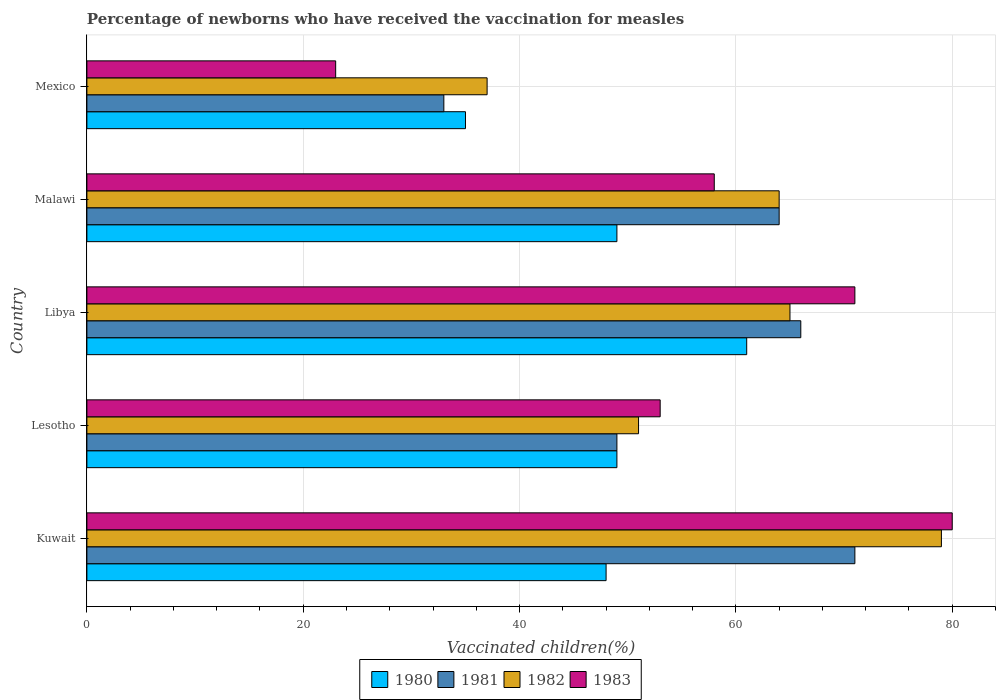How many different coloured bars are there?
Provide a succinct answer. 4. Are the number of bars on each tick of the Y-axis equal?
Keep it short and to the point. Yes. What is the label of the 2nd group of bars from the top?
Your answer should be very brief. Malawi. In how many cases, is the number of bars for a given country not equal to the number of legend labels?
Offer a terse response. 0. What is the percentage of vaccinated children in 1983 in Mexico?
Make the answer very short. 23. Across all countries, what is the maximum percentage of vaccinated children in 1980?
Provide a succinct answer. 61. In which country was the percentage of vaccinated children in 1982 maximum?
Offer a very short reply. Kuwait. In which country was the percentage of vaccinated children in 1982 minimum?
Provide a short and direct response. Mexico. What is the total percentage of vaccinated children in 1980 in the graph?
Your response must be concise. 242. What is the difference between the percentage of vaccinated children in 1983 in Lesotho and that in Mexico?
Provide a succinct answer. 30. What is the difference between the percentage of vaccinated children in 1981 in Lesotho and the percentage of vaccinated children in 1980 in Libya?
Give a very brief answer. -12. What is the average percentage of vaccinated children in 1981 per country?
Your response must be concise. 56.6. In how many countries, is the percentage of vaccinated children in 1983 greater than 24 %?
Your answer should be very brief. 4. What is the ratio of the percentage of vaccinated children in 1981 in Lesotho to that in Libya?
Offer a very short reply. 0.74. What is the difference between the highest and the lowest percentage of vaccinated children in 1982?
Make the answer very short. 42. Is it the case that in every country, the sum of the percentage of vaccinated children in 1981 and percentage of vaccinated children in 1983 is greater than the percentage of vaccinated children in 1982?
Your response must be concise. Yes. Are all the bars in the graph horizontal?
Offer a terse response. Yes. How many countries are there in the graph?
Offer a terse response. 5. Does the graph contain any zero values?
Make the answer very short. No. Does the graph contain grids?
Your response must be concise. Yes. How are the legend labels stacked?
Your answer should be compact. Horizontal. What is the title of the graph?
Offer a very short reply. Percentage of newborns who have received the vaccination for measles. What is the label or title of the X-axis?
Give a very brief answer. Vaccinated children(%). What is the Vaccinated children(%) of 1982 in Kuwait?
Your answer should be compact. 79. What is the Vaccinated children(%) in 1983 in Kuwait?
Provide a short and direct response. 80. What is the Vaccinated children(%) of 1980 in Lesotho?
Offer a terse response. 49. What is the Vaccinated children(%) of 1981 in Lesotho?
Provide a succinct answer. 49. What is the Vaccinated children(%) in 1980 in Malawi?
Make the answer very short. 49. What is the Vaccinated children(%) of 1981 in Malawi?
Give a very brief answer. 64. What is the Vaccinated children(%) of 1982 in Malawi?
Make the answer very short. 64. What is the Vaccinated children(%) of 1983 in Malawi?
Keep it short and to the point. 58. Across all countries, what is the maximum Vaccinated children(%) of 1980?
Provide a short and direct response. 61. Across all countries, what is the maximum Vaccinated children(%) in 1982?
Offer a very short reply. 79. Across all countries, what is the maximum Vaccinated children(%) of 1983?
Make the answer very short. 80. Across all countries, what is the minimum Vaccinated children(%) in 1980?
Give a very brief answer. 35. What is the total Vaccinated children(%) of 1980 in the graph?
Provide a short and direct response. 242. What is the total Vaccinated children(%) in 1981 in the graph?
Give a very brief answer. 283. What is the total Vaccinated children(%) in 1982 in the graph?
Provide a short and direct response. 296. What is the total Vaccinated children(%) of 1983 in the graph?
Offer a terse response. 285. What is the difference between the Vaccinated children(%) of 1980 in Kuwait and that in Lesotho?
Your answer should be compact. -1. What is the difference between the Vaccinated children(%) in 1981 in Kuwait and that in Lesotho?
Provide a short and direct response. 22. What is the difference between the Vaccinated children(%) in 1983 in Kuwait and that in Lesotho?
Your answer should be compact. 27. What is the difference between the Vaccinated children(%) of 1981 in Kuwait and that in Libya?
Your answer should be very brief. 5. What is the difference between the Vaccinated children(%) of 1983 in Kuwait and that in Libya?
Ensure brevity in your answer.  9. What is the difference between the Vaccinated children(%) in 1983 in Kuwait and that in Malawi?
Give a very brief answer. 22. What is the difference between the Vaccinated children(%) of 1980 in Kuwait and that in Mexico?
Make the answer very short. 13. What is the difference between the Vaccinated children(%) in 1981 in Kuwait and that in Mexico?
Provide a short and direct response. 38. What is the difference between the Vaccinated children(%) in 1983 in Kuwait and that in Mexico?
Ensure brevity in your answer.  57. What is the difference between the Vaccinated children(%) in 1981 in Lesotho and that in Libya?
Provide a succinct answer. -17. What is the difference between the Vaccinated children(%) in 1982 in Lesotho and that in Malawi?
Offer a terse response. -13. What is the difference between the Vaccinated children(%) of 1983 in Lesotho and that in Malawi?
Keep it short and to the point. -5. What is the difference between the Vaccinated children(%) of 1980 in Lesotho and that in Mexico?
Your answer should be compact. 14. What is the difference between the Vaccinated children(%) in 1983 in Lesotho and that in Mexico?
Ensure brevity in your answer.  30. What is the difference between the Vaccinated children(%) in 1980 in Libya and that in Malawi?
Provide a short and direct response. 12. What is the difference between the Vaccinated children(%) of 1982 in Libya and that in Malawi?
Provide a succinct answer. 1. What is the difference between the Vaccinated children(%) in 1983 in Libya and that in Malawi?
Offer a very short reply. 13. What is the difference between the Vaccinated children(%) in 1983 in Libya and that in Mexico?
Your answer should be very brief. 48. What is the difference between the Vaccinated children(%) in 1980 in Malawi and that in Mexico?
Give a very brief answer. 14. What is the difference between the Vaccinated children(%) of 1981 in Malawi and that in Mexico?
Provide a short and direct response. 31. What is the difference between the Vaccinated children(%) in 1980 in Kuwait and the Vaccinated children(%) in 1982 in Lesotho?
Provide a short and direct response. -3. What is the difference between the Vaccinated children(%) of 1980 in Kuwait and the Vaccinated children(%) of 1983 in Lesotho?
Ensure brevity in your answer.  -5. What is the difference between the Vaccinated children(%) of 1981 in Kuwait and the Vaccinated children(%) of 1982 in Lesotho?
Your answer should be compact. 20. What is the difference between the Vaccinated children(%) of 1981 in Kuwait and the Vaccinated children(%) of 1983 in Lesotho?
Your answer should be compact. 18. What is the difference between the Vaccinated children(%) in 1982 in Kuwait and the Vaccinated children(%) in 1983 in Lesotho?
Your answer should be compact. 26. What is the difference between the Vaccinated children(%) of 1980 in Kuwait and the Vaccinated children(%) of 1981 in Libya?
Provide a succinct answer. -18. What is the difference between the Vaccinated children(%) of 1981 in Kuwait and the Vaccinated children(%) of 1983 in Libya?
Offer a very short reply. 0. What is the difference between the Vaccinated children(%) in 1980 in Kuwait and the Vaccinated children(%) in 1981 in Malawi?
Ensure brevity in your answer.  -16. What is the difference between the Vaccinated children(%) of 1980 in Kuwait and the Vaccinated children(%) of 1982 in Malawi?
Offer a terse response. -16. What is the difference between the Vaccinated children(%) in 1980 in Kuwait and the Vaccinated children(%) in 1983 in Malawi?
Your answer should be very brief. -10. What is the difference between the Vaccinated children(%) of 1981 in Kuwait and the Vaccinated children(%) of 1982 in Malawi?
Offer a terse response. 7. What is the difference between the Vaccinated children(%) of 1980 in Kuwait and the Vaccinated children(%) of 1982 in Mexico?
Your answer should be very brief. 11. What is the difference between the Vaccinated children(%) of 1980 in Lesotho and the Vaccinated children(%) of 1983 in Libya?
Make the answer very short. -22. What is the difference between the Vaccinated children(%) in 1981 in Lesotho and the Vaccinated children(%) in 1982 in Libya?
Your answer should be compact. -16. What is the difference between the Vaccinated children(%) of 1982 in Lesotho and the Vaccinated children(%) of 1983 in Libya?
Ensure brevity in your answer.  -20. What is the difference between the Vaccinated children(%) in 1980 in Lesotho and the Vaccinated children(%) in 1982 in Malawi?
Your answer should be compact. -15. What is the difference between the Vaccinated children(%) of 1981 in Lesotho and the Vaccinated children(%) of 1982 in Malawi?
Provide a short and direct response. -15. What is the difference between the Vaccinated children(%) in 1982 in Lesotho and the Vaccinated children(%) in 1983 in Malawi?
Provide a short and direct response. -7. What is the difference between the Vaccinated children(%) of 1980 in Lesotho and the Vaccinated children(%) of 1982 in Mexico?
Keep it short and to the point. 12. What is the difference between the Vaccinated children(%) of 1980 in Lesotho and the Vaccinated children(%) of 1983 in Mexico?
Offer a terse response. 26. What is the difference between the Vaccinated children(%) in 1981 in Lesotho and the Vaccinated children(%) in 1982 in Mexico?
Your answer should be compact. 12. What is the difference between the Vaccinated children(%) in 1982 in Lesotho and the Vaccinated children(%) in 1983 in Mexico?
Provide a succinct answer. 28. What is the difference between the Vaccinated children(%) of 1980 in Libya and the Vaccinated children(%) of 1982 in Malawi?
Offer a very short reply. -3. What is the difference between the Vaccinated children(%) in 1980 in Libya and the Vaccinated children(%) in 1983 in Malawi?
Your response must be concise. 3. What is the difference between the Vaccinated children(%) of 1980 in Malawi and the Vaccinated children(%) of 1981 in Mexico?
Make the answer very short. 16. What is the difference between the Vaccinated children(%) in 1980 in Malawi and the Vaccinated children(%) in 1982 in Mexico?
Your response must be concise. 12. What is the difference between the Vaccinated children(%) in 1981 in Malawi and the Vaccinated children(%) in 1983 in Mexico?
Give a very brief answer. 41. What is the difference between the Vaccinated children(%) of 1982 in Malawi and the Vaccinated children(%) of 1983 in Mexico?
Give a very brief answer. 41. What is the average Vaccinated children(%) of 1980 per country?
Offer a very short reply. 48.4. What is the average Vaccinated children(%) of 1981 per country?
Your answer should be compact. 56.6. What is the average Vaccinated children(%) in 1982 per country?
Give a very brief answer. 59.2. What is the average Vaccinated children(%) of 1983 per country?
Provide a short and direct response. 57. What is the difference between the Vaccinated children(%) of 1980 and Vaccinated children(%) of 1982 in Kuwait?
Offer a very short reply. -31. What is the difference between the Vaccinated children(%) of 1980 and Vaccinated children(%) of 1983 in Kuwait?
Your response must be concise. -32. What is the difference between the Vaccinated children(%) of 1981 and Vaccinated children(%) of 1982 in Kuwait?
Provide a short and direct response. -8. What is the difference between the Vaccinated children(%) of 1981 and Vaccinated children(%) of 1983 in Kuwait?
Offer a very short reply. -9. What is the difference between the Vaccinated children(%) in 1982 and Vaccinated children(%) in 1983 in Kuwait?
Make the answer very short. -1. What is the difference between the Vaccinated children(%) of 1980 and Vaccinated children(%) of 1981 in Lesotho?
Your response must be concise. 0. What is the difference between the Vaccinated children(%) of 1980 and Vaccinated children(%) of 1982 in Lesotho?
Give a very brief answer. -2. What is the difference between the Vaccinated children(%) in 1980 and Vaccinated children(%) in 1983 in Lesotho?
Keep it short and to the point. -4. What is the difference between the Vaccinated children(%) in 1980 and Vaccinated children(%) in 1983 in Libya?
Your answer should be compact. -10. What is the difference between the Vaccinated children(%) in 1982 and Vaccinated children(%) in 1983 in Libya?
Give a very brief answer. -6. What is the difference between the Vaccinated children(%) of 1980 and Vaccinated children(%) of 1981 in Malawi?
Your response must be concise. -15. What is the difference between the Vaccinated children(%) of 1981 and Vaccinated children(%) of 1982 in Malawi?
Ensure brevity in your answer.  0. What is the difference between the Vaccinated children(%) in 1980 and Vaccinated children(%) in 1983 in Mexico?
Ensure brevity in your answer.  12. What is the difference between the Vaccinated children(%) in 1981 and Vaccinated children(%) in 1983 in Mexico?
Offer a very short reply. 10. What is the ratio of the Vaccinated children(%) of 1980 in Kuwait to that in Lesotho?
Ensure brevity in your answer.  0.98. What is the ratio of the Vaccinated children(%) in 1981 in Kuwait to that in Lesotho?
Offer a very short reply. 1.45. What is the ratio of the Vaccinated children(%) of 1982 in Kuwait to that in Lesotho?
Provide a succinct answer. 1.55. What is the ratio of the Vaccinated children(%) in 1983 in Kuwait to that in Lesotho?
Make the answer very short. 1.51. What is the ratio of the Vaccinated children(%) of 1980 in Kuwait to that in Libya?
Make the answer very short. 0.79. What is the ratio of the Vaccinated children(%) in 1981 in Kuwait to that in Libya?
Provide a succinct answer. 1.08. What is the ratio of the Vaccinated children(%) of 1982 in Kuwait to that in Libya?
Your answer should be compact. 1.22. What is the ratio of the Vaccinated children(%) of 1983 in Kuwait to that in Libya?
Make the answer very short. 1.13. What is the ratio of the Vaccinated children(%) of 1980 in Kuwait to that in Malawi?
Make the answer very short. 0.98. What is the ratio of the Vaccinated children(%) of 1981 in Kuwait to that in Malawi?
Give a very brief answer. 1.11. What is the ratio of the Vaccinated children(%) in 1982 in Kuwait to that in Malawi?
Your response must be concise. 1.23. What is the ratio of the Vaccinated children(%) in 1983 in Kuwait to that in Malawi?
Your answer should be very brief. 1.38. What is the ratio of the Vaccinated children(%) of 1980 in Kuwait to that in Mexico?
Your answer should be compact. 1.37. What is the ratio of the Vaccinated children(%) in 1981 in Kuwait to that in Mexico?
Your response must be concise. 2.15. What is the ratio of the Vaccinated children(%) of 1982 in Kuwait to that in Mexico?
Make the answer very short. 2.14. What is the ratio of the Vaccinated children(%) of 1983 in Kuwait to that in Mexico?
Make the answer very short. 3.48. What is the ratio of the Vaccinated children(%) in 1980 in Lesotho to that in Libya?
Make the answer very short. 0.8. What is the ratio of the Vaccinated children(%) of 1981 in Lesotho to that in Libya?
Ensure brevity in your answer.  0.74. What is the ratio of the Vaccinated children(%) in 1982 in Lesotho to that in Libya?
Offer a terse response. 0.78. What is the ratio of the Vaccinated children(%) of 1983 in Lesotho to that in Libya?
Offer a very short reply. 0.75. What is the ratio of the Vaccinated children(%) in 1980 in Lesotho to that in Malawi?
Give a very brief answer. 1. What is the ratio of the Vaccinated children(%) in 1981 in Lesotho to that in Malawi?
Provide a short and direct response. 0.77. What is the ratio of the Vaccinated children(%) in 1982 in Lesotho to that in Malawi?
Your response must be concise. 0.8. What is the ratio of the Vaccinated children(%) of 1983 in Lesotho to that in Malawi?
Make the answer very short. 0.91. What is the ratio of the Vaccinated children(%) of 1981 in Lesotho to that in Mexico?
Keep it short and to the point. 1.48. What is the ratio of the Vaccinated children(%) of 1982 in Lesotho to that in Mexico?
Offer a very short reply. 1.38. What is the ratio of the Vaccinated children(%) in 1983 in Lesotho to that in Mexico?
Your answer should be very brief. 2.3. What is the ratio of the Vaccinated children(%) in 1980 in Libya to that in Malawi?
Offer a very short reply. 1.24. What is the ratio of the Vaccinated children(%) in 1981 in Libya to that in Malawi?
Offer a terse response. 1.03. What is the ratio of the Vaccinated children(%) in 1982 in Libya to that in Malawi?
Offer a very short reply. 1.02. What is the ratio of the Vaccinated children(%) in 1983 in Libya to that in Malawi?
Your response must be concise. 1.22. What is the ratio of the Vaccinated children(%) in 1980 in Libya to that in Mexico?
Ensure brevity in your answer.  1.74. What is the ratio of the Vaccinated children(%) of 1982 in Libya to that in Mexico?
Make the answer very short. 1.76. What is the ratio of the Vaccinated children(%) of 1983 in Libya to that in Mexico?
Your answer should be compact. 3.09. What is the ratio of the Vaccinated children(%) of 1981 in Malawi to that in Mexico?
Your response must be concise. 1.94. What is the ratio of the Vaccinated children(%) of 1982 in Malawi to that in Mexico?
Your response must be concise. 1.73. What is the ratio of the Vaccinated children(%) in 1983 in Malawi to that in Mexico?
Offer a terse response. 2.52. What is the difference between the highest and the second highest Vaccinated children(%) of 1980?
Provide a succinct answer. 12. What is the difference between the highest and the second highest Vaccinated children(%) of 1982?
Your answer should be very brief. 14. What is the difference between the highest and the second highest Vaccinated children(%) of 1983?
Your answer should be compact. 9. What is the difference between the highest and the lowest Vaccinated children(%) in 1980?
Give a very brief answer. 26. What is the difference between the highest and the lowest Vaccinated children(%) in 1981?
Make the answer very short. 38. 